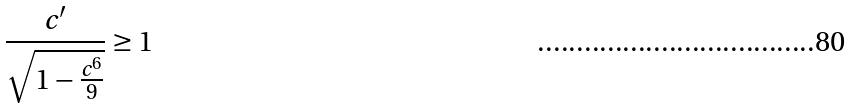Convert formula to latex. <formula><loc_0><loc_0><loc_500><loc_500>\frac { c ^ { \prime } } { \sqrt { 1 - \frac { c ^ { 6 } } { 9 } } } \geq 1</formula> 